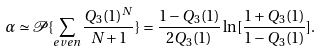<formula> <loc_0><loc_0><loc_500><loc_500>\alpha \simeq \mathcal { P } \{ \sum _ { e v e n } \frac { Q _ { 3 } ( 1 ) ^ { N } } { N + 1 } \} = \frac { 1 - Q _ { 3 } ( 1 ) } { 2 Q _ { 3 } ( 1 ) } \ln [ \frac { 1 + Q _ { 3 } ( 1 ) } { 1 - Q _ { 3 } ( 1 ) } ] .</formula> 